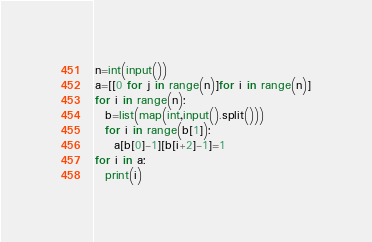<code> <loc_0><loc_0><loc_500><loc_500><_Python_>n=int(input())
a=[[0 for j in range(n)]for i in range(n)]
for i in range(n):
  b=list(map(int,input().split()))
  for i in range(b[1]):
    a[b[0]-1][b[i+2]-1]=1
for i in a:
  print(i)
</code> 